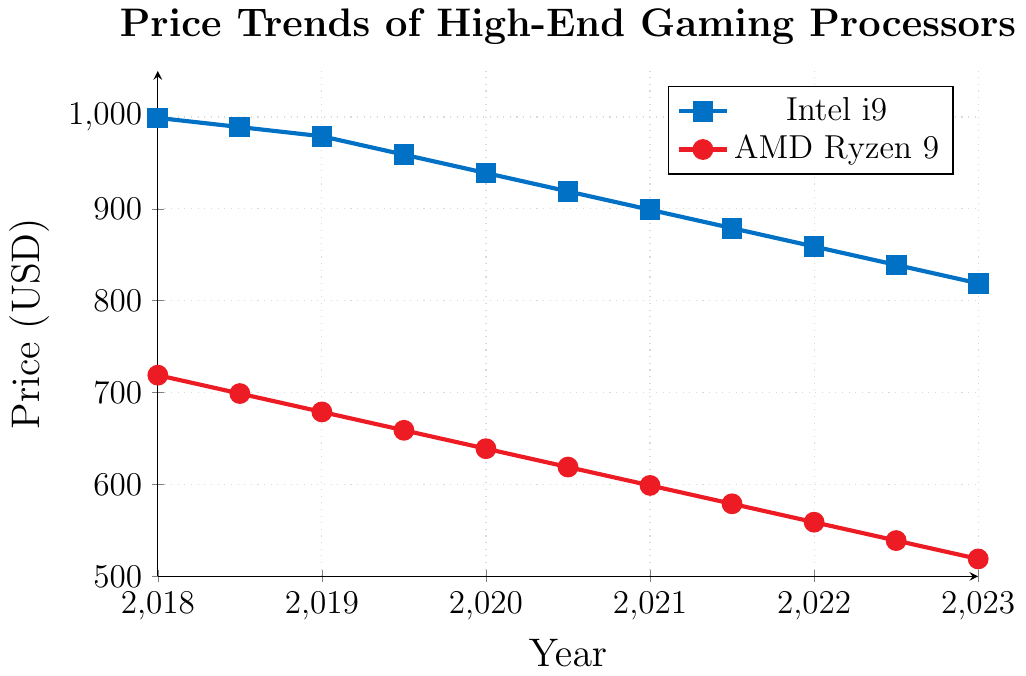What is the price of the Intel i9 processor in 2021? To find the price of the Intel i9 processor in 2021, locate the year 2021 on the x-axis. Trace vertically until you hit the Intel i9 line (blue with square markers), then trace horizontally to the y-axis to read the price.
Answer: 899 How much did the price of the AMD Ryzen 9 processor decrease from 2018 to 2023? To calculate the decrease, identify the prices in 2018 and 2023 on the AMD Ryzen 9 line (red with circular markers). Subtract the 2023 price (519) from the 2018 price (719).
Answer: 200 Which processor had a steeper price decline between 2018 and 2023? Compare the slopes of the Intel i9 and AMD Ryzen 9 lines from 2018 to 2023. Determine the difference in prices for both processors over this period and see which has the larger absolute value.
Answer: Intel i9 What is the average price of the Intel i9 processor from 2018 to 2023? Calculate the average by summing the prices at all the given data points for the Intel i9, then divide by the number of data points. (999 + 989 + 979 + 959 + 939 + 919 + 899 + 879 + 859 + 839 + 819) / 11 = 918
Answer: 918 In which year did the prices of both processors differ the most? Calculate the price difference for each year. Compare these differences to find the maximum. The year when the absolute difference between Intel i9 and AMD Ryzen 9 is the largest will be the answer. Differences: (2018: 280, 2018.5: 290, 2019: 300, 2019.5: 300, 2020: 300, 2020.5: 300, 2021: 300, 2021.5: 300, 2022: 300, 2022.5: 300, 2023: 300).
Answer: 2018.5 At what year was the price of Intel i9 equal to twice the price of AMD Ryzen 9? Identify the years where the price of Intel i9 is double that of AMD Ryzen 9 by examining the given coordinates. Check each year to see if the condition holds true.
Answer: This condition is not met in any provided year What is the pattern of price decline for AMD Ryzen 9 each half year from 2018 to 2023? Observe the AMD Ryzen 9 line (red with circular markers) and note the price differences between consecutive data points over half-year intervals. The pattern shows a consistent decrease. Typically, the price decreases by 20 USD every half year.
Answer: Decreasing by 20 USD every half year Which processor was more expensive in 2020, and by how much? Compare the prices of both processors in 2020 by reading the values from the respective lines. Subtract the AMD Ryzen 9 price (639) from the Intel i9 price (939).
Answer: Intel i9 by 300 USD What is the total price decrease for Intel i9 from 2018 to 2023? Calculate the total decrease by subtracting the 2023 Intel i9 price (819) from the 2018 price (999).
Answer: 180 Find the percentage price decrease for AMD Ryzen 9 from 2018 to 2023. Calculate the percentage decrease by subtracting the 2023 price from the 2018 price, then divide by the 2018 price and multiply by 100. ((719 - 519) / 719) * 100
Answer: 27.8% 